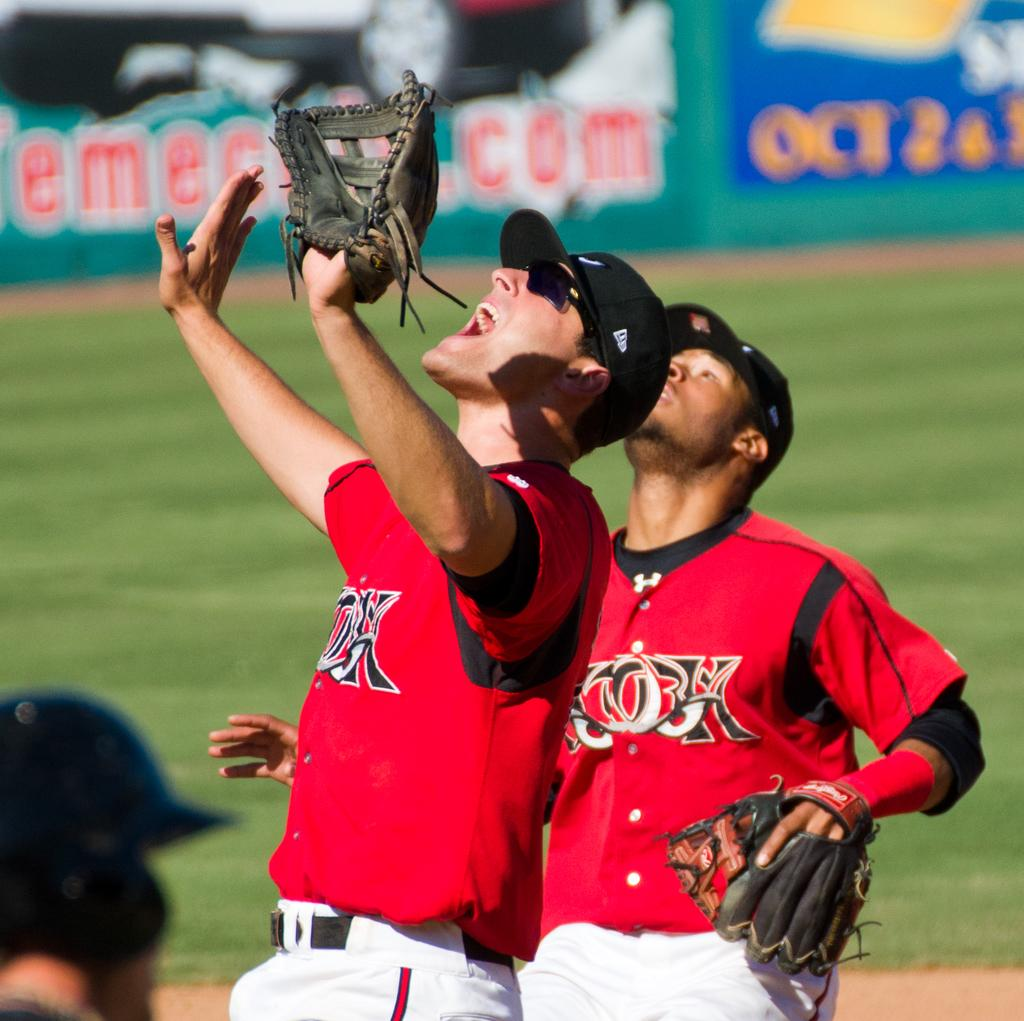<image>
Describe the image concisely. Players wearing red jerseys stand near a sign in the background that says Oct. 2 & 3 